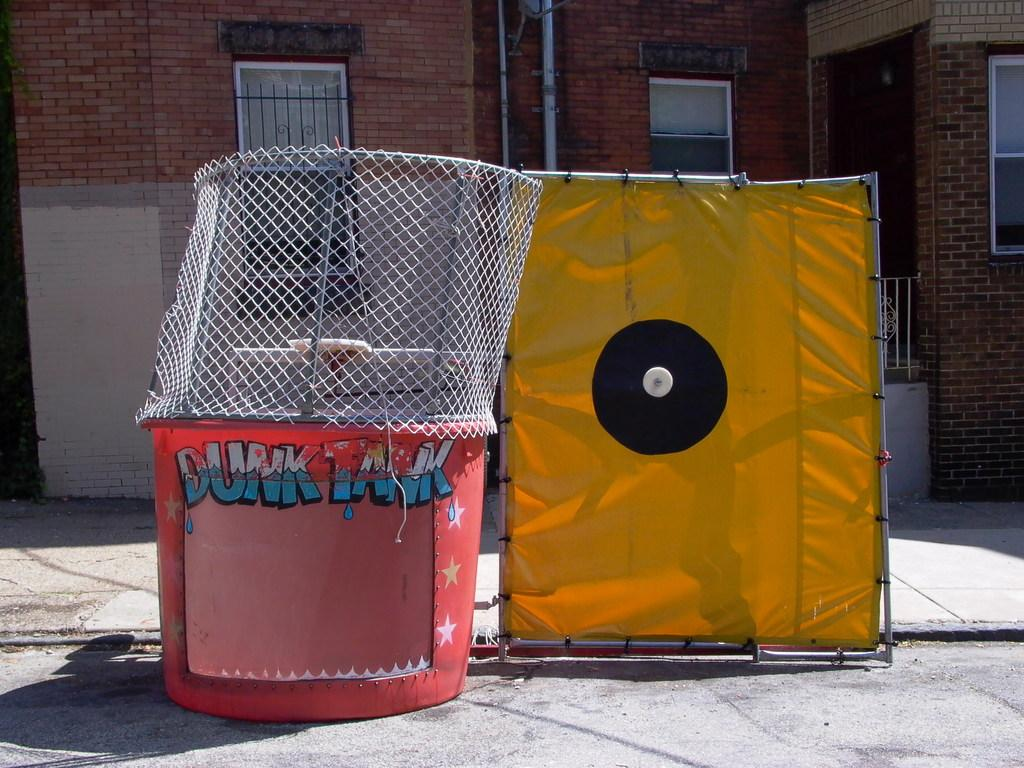<image>
Give a short and clear explanation of the subsequent image. a dunk tank looks like it needs some work to make it safe 